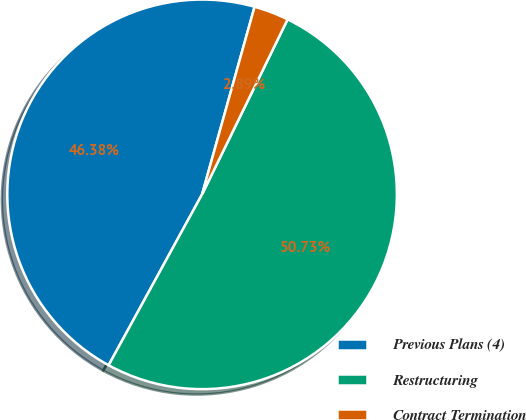Convert chart to OTSL. <chart><loc_0><loc_0><loc_500><loc_500><pie_chart><fcel>Previous Plans (4)<fcel>Restructuring<fcel>Contract Termination<nl><fcel>46.38%<fcel>50.73%<fcel>2.89%<nl></chart> 